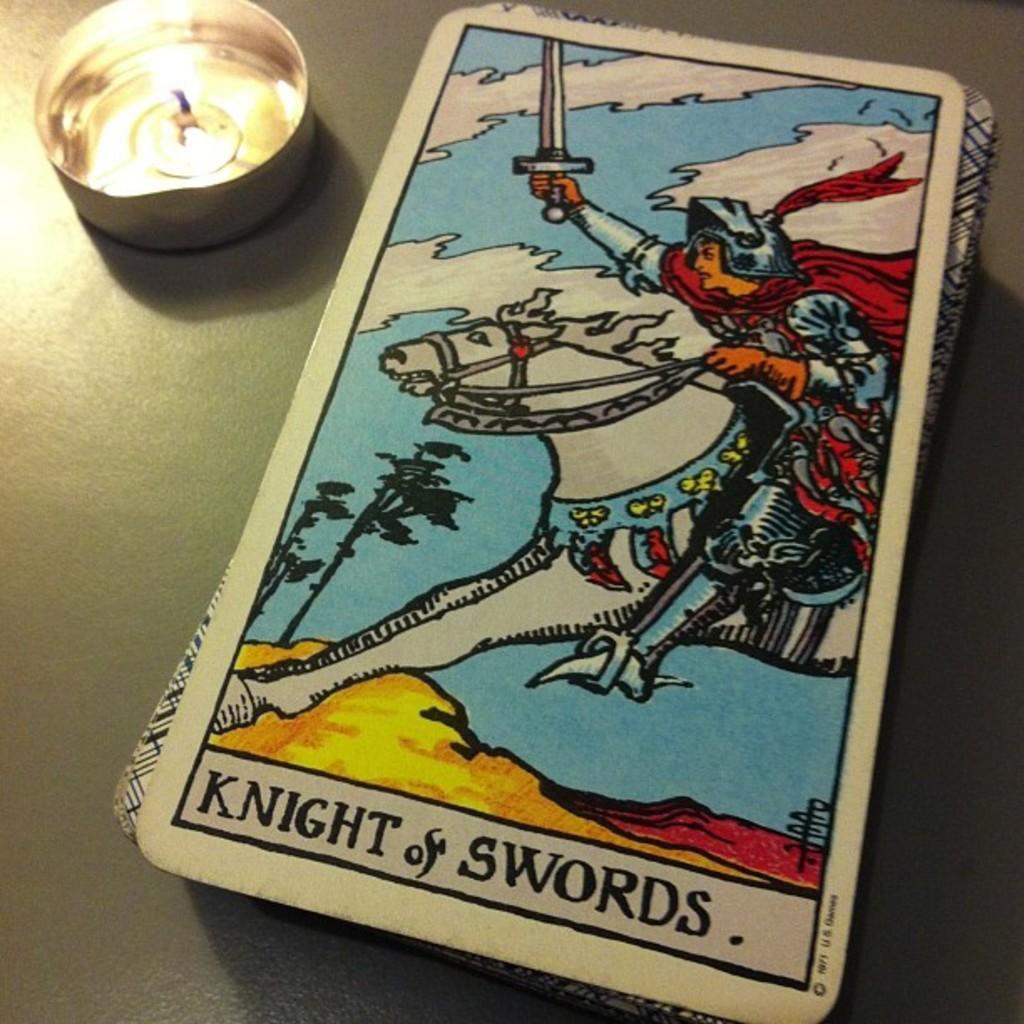Describe this image in one or two sentences. In this image there are cards one above the other on the right side. On the left side there is a candle in the bowl. 